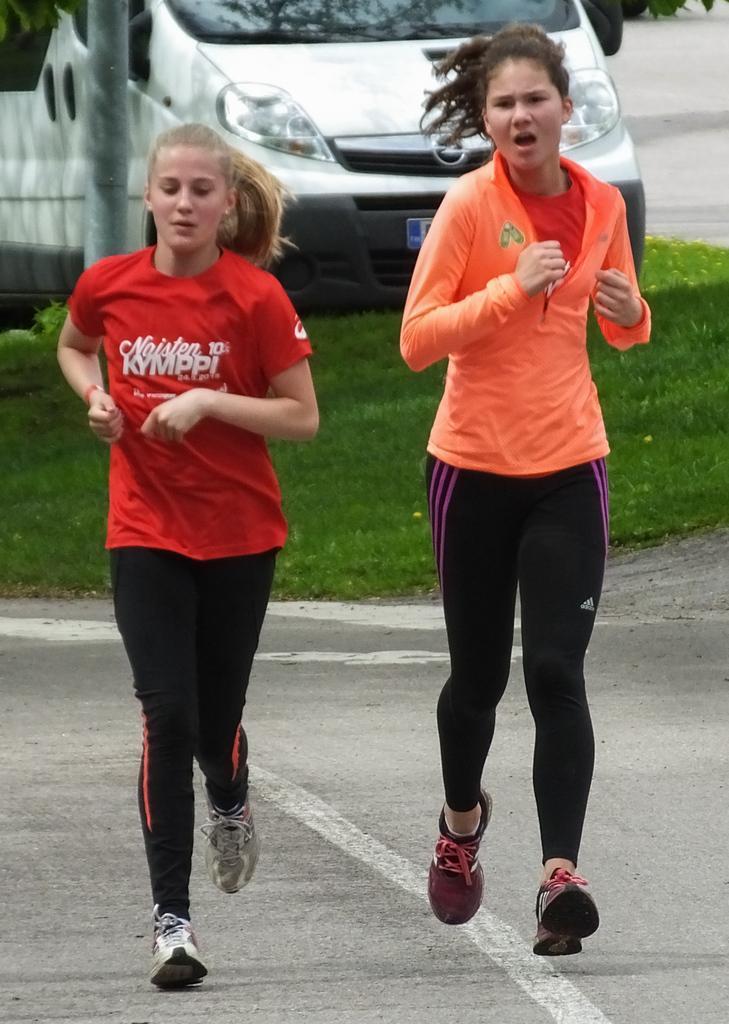Can you describe this image briefly? In this image there are two girls running on the road, behind them there is a vehicle parked on the surface of the grass, beside the vehicle there is a pole. 